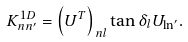Convert formula to latex. <formula><loc_0><loc_0><loc_500><loc_500>K _ { n n ^ { \prime } } ^ { 1 D } = \left ( U ^ { T } \right ) _ { n l } \tan \delta _ { l } U _ { \ln ^ { \prime } } .</formula> 